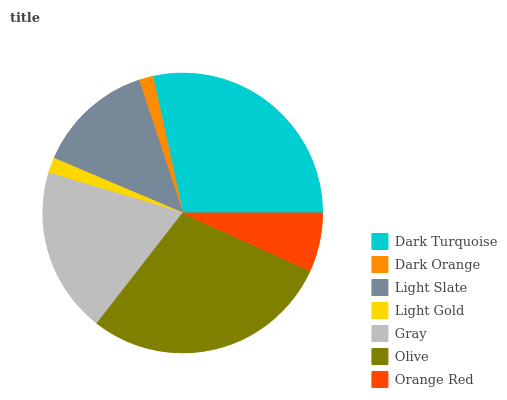Is Dark Orange the minimum?
Answer yes or no. Yes. Is Olive the maximum?
Answer yes or no. Yes. Is Light Slate the minimum?
Answer yes or no. No. Is Light Slate the maximum?
Answer yes or no. No. Is Light Slate greater than Dark Orange?
Answer yes or no. Yes. Is Dark Orange less than Light Slate?
Answer yes or no. Yes. Is Dark Orange greater than Light Slate?
Answer yes or no. No. Is Light Slate less than Dark Orange?
Answer yes or no. No. Is Light Slate the high median?
Answer yes or no. Yes. Is Light Slate the low median?
Answer yes or no. Yes. Is Dark Turquoise the high median?
Answer yes or no. No. Is Gray the low median?
Answer yes or no. No. 